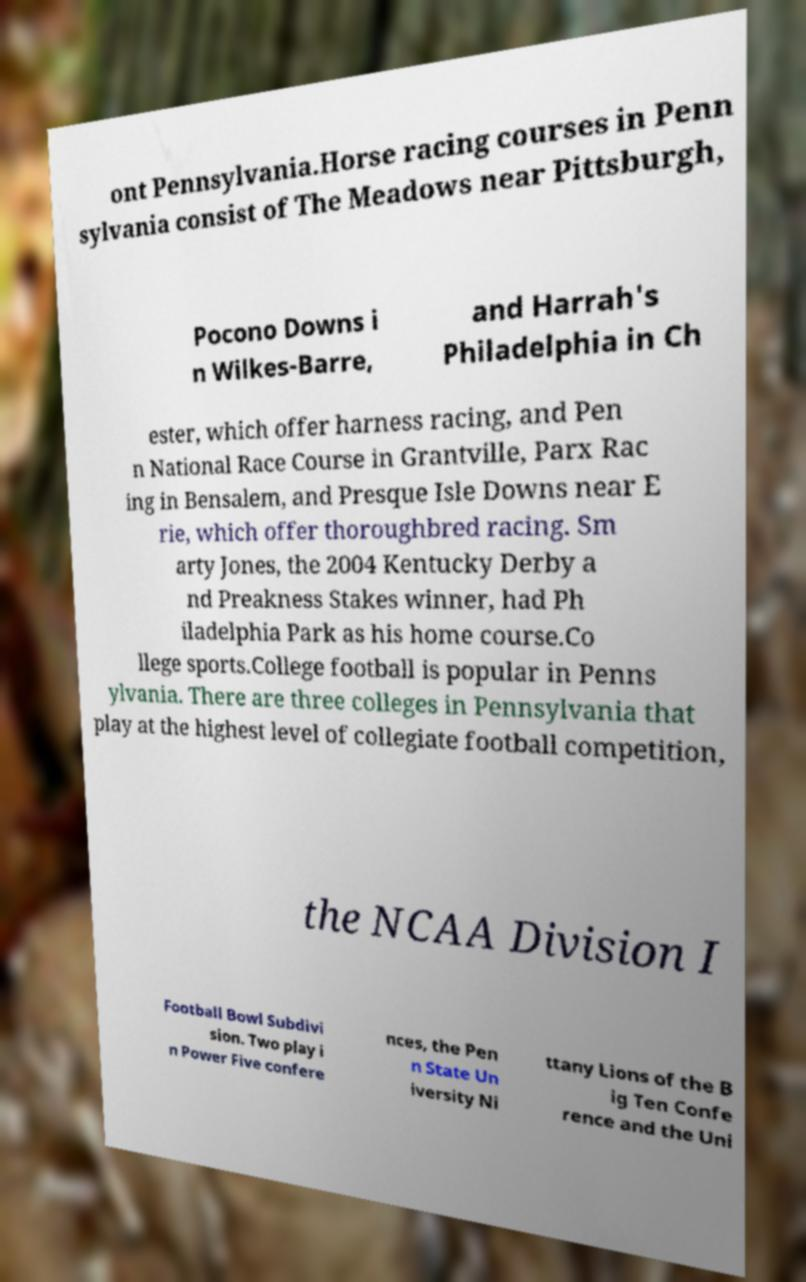Please read and relay the text visible in this image. What does it say? ont Pennsylvania.Horse racing courses in Penn sylvania consist of The Meadows near Pittsburgh, Pocono Downs i n Wilkes-Barre, and Harrah's Philadelphia in Ch ester, which offer harness racing, and Pen n National Race Course in Grantville, Parx Rac ing in Bensalem, and Presque Isle Downs near E rie, which offer thoroughbred racing. Sm arty Jones, the 2004 Kentucky Derby a nd Preakness Stakes winner, had Ph iladelphia Park as his home course.Co llege sports.College football is popular in Penns ylvania. There are three colleges in Pennsylvania that play at the highest level of collegiate football competition, the NCAA Division I Football Bowl Subdivi sion. Two play i n Power Five confere nces, the Pen n State Un iversity Ni ttany Lions of the B ig Ten Confe rence and the Uni 